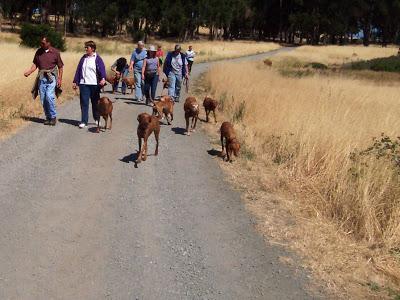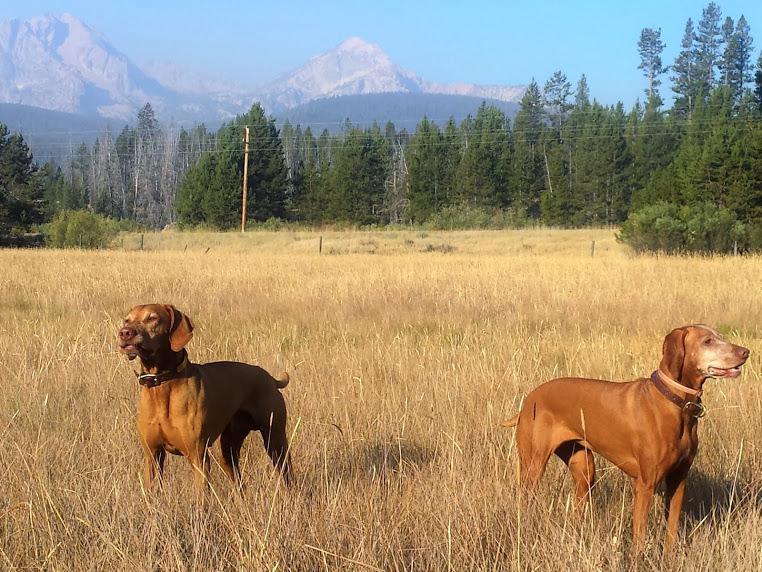The first image is the image on the left, the second image is the image on the right. Given the left and right images, does the statement "One person is riding a bicycle near two dogs." hold true? Answer yes or no. No. The first image is the image on the left, the second image is the image on the right. Examine the images to the left and right. Is the description "An image shows two red-orange dogs and a bike rider going down the same path." accurate? Answer yes or no. No. 